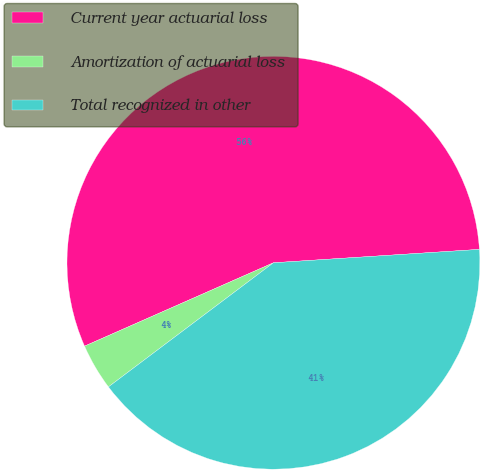Convert chart. <chart><loc_0><loc_0><loc_500><loc_500><pie_chart><fcel>Current year actuarial loss<fcel>Amortization of actuarial loss<fcel>Total recognized in other<nl><fcel>55.58%<fcel>3.65%<fcel>40.77%<nl></chart> 